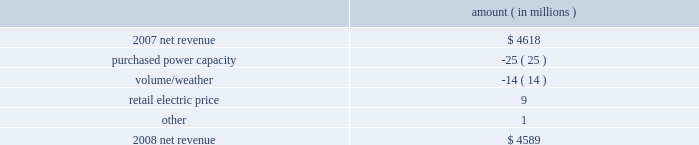Entergy corporation and subsidiaries management's financial discussion and analysis the expenses related to the voluntary severance program offered to employees .
Approximately 200 employees from the non-utility nuclear business and 150 employees in the utility business accepted the voluntary severance program offers .
Net revenue utility following is an analysis of the change in net revenue comparing 2008 to 2007 .
Amount ( in millions ) .
The purchased power capacity variance is primarily due to higher capacity charges .
A portion of the variance is due to the amortization of deferred capacity costs and is offset in base revenues due to base rate increases implemented to recover incremental deferred and ongoing purchased power capacity charges .
The volume/weather variance is primarily due to the effect of less favorable weather compared to the same period in 2007 and decreased electricity usage primarily during the unbilled sales period .
Hurricane gustav and hurricane ike , which hit the utility's service territories in september 2008 , contributed an estimated $ 46 million to the decrease in electricity usage .
Industrial sales were also depressed by the continuing effects of the hurricanes and , especially in the latter part of the year , because of the overall decline of the economy , leading to lower usage in the latter part of the year affecting both the large customer industrial segment as well as small and mid-sized industrial customers .
The decreases in electricity usage were partially offset by an increase in residential and commercial customer electricity usage that occurred during the periods of the year not affected by the hurricanes .
The retail electric price variance is primarily due to : an increase in the attala power plant costs recovered through the power management rider by entergy mississippi .
The net income effect of this recovery is limited to a portion representing an allowed return on equity with the remainder offset by attala power plant costs in other operation and maintenance expenses , depreciation expenses , and taxes other than income taxes ; a storm damage rider that became effective in october 2007 at entergy mississippi ; and an energy efficiency rider that became effective in november 2007 at entergy arkansas .
The establishment of the storm damage rider and the energy efficiency rider results in an increase in rider revenue and a corresponding increase in other operation and maintenance expense with no impact on net income .
The retail electric price variance was partially offset by : the absence of interim storm recoveries through the formula rate plans at entergy louisiana and entergy gulf states louisiana which ceased upon the act 55 financing of storm costs in the third quarter 2008 ; and a credit passed on to customers as a result of the act 55 storm cost financings .
Refer to "liquidity and capital resources - hurricane katrina and hurricane rita" below and note 2 to the financial statements for a discussion of the interim recovery of storm costs and the act 55 storm cost financings. .
What was the percent of net revenue utility change in net revenue? 
Computations: ((4589 - 4618) / 4618)
Answer: -0.00628. 